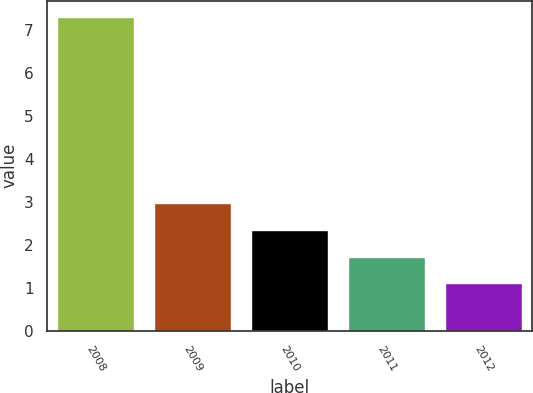Convert chart. <chart><loc_0><loc_0><loc_500><loc_500><bar_chart><fcel>2008<fcel>2009<fcel>2010<fcel>2011<fcel>2012<nl><fcel>7.3<fcel>2.96<fcel>2.34<fcel>1.72<fcel>1.1<nl></chart> 